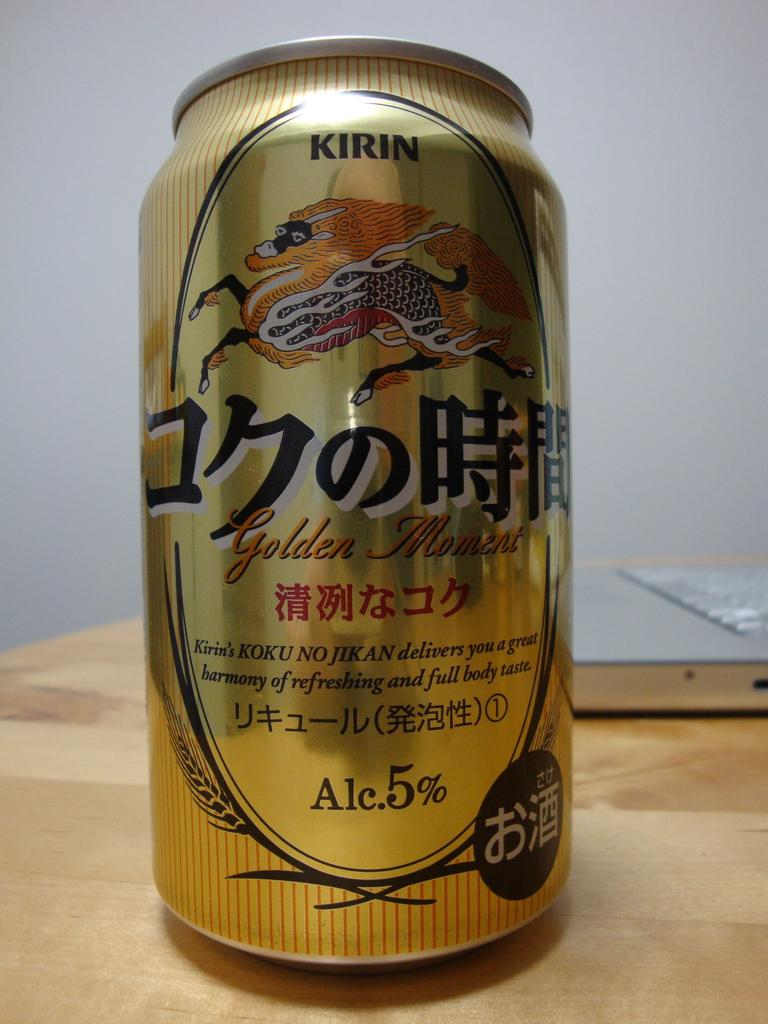<image>
Give a short and clear explanation of the subsequent image. A kirin brand Golden Moment can of beer. 